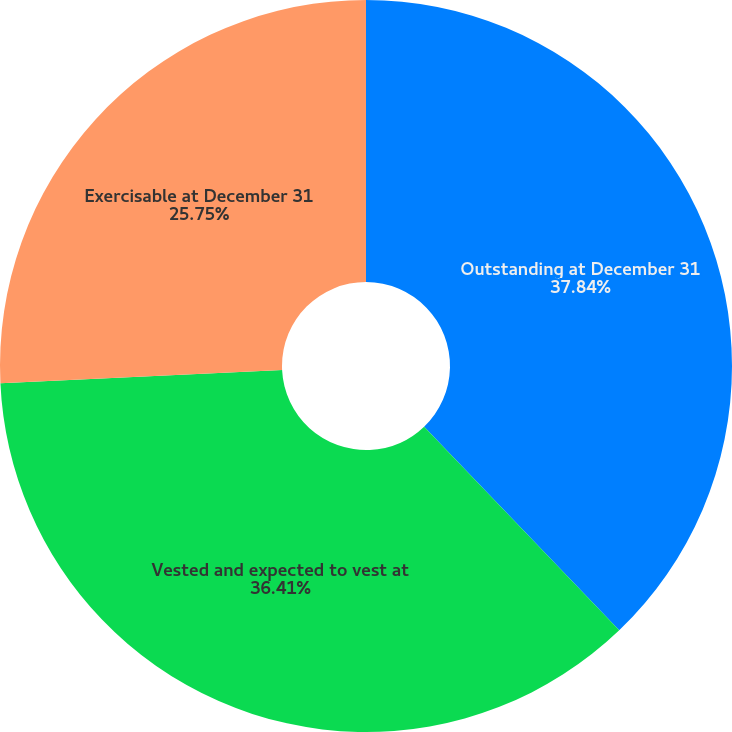Convert chart. <chart><loc_0><loc_0><loc_500><loc_500><pie_chart><fcel>Outstanding at December 31<fcel>Vested and expected to vest at<fcel>Exercisable at December 31<nl><fcel>37.84%<fcel>36.41%<fcel>25.75%<nl></chart> 